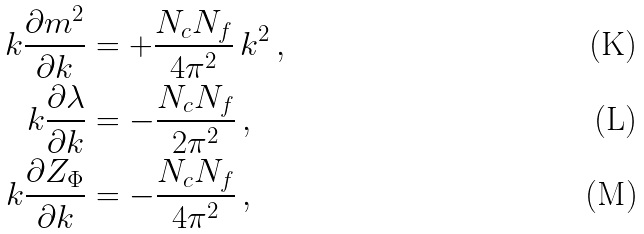<formula> <loc_0><loc_0><loc_500><loc_500>k \frac { \partial m ^ { 2 } } { \partial k } & = + \frac { N _ { c } N _ { f } } { 4 \pi ^ { 2 } } \, k ^ { 2 } \, , \\ k \frac { \partial \lambda } { \partial k } & = - \frac { N _ { c } N _ { f } } { 2 \pi ^ { 2 } } \, , \\ k \frac { \partial Z _ { \Phi } } { \partial k } & = - \frac { N _ { c } N _ { f } } { 4 \pi ^ { 2 } } \, ,</formula> 